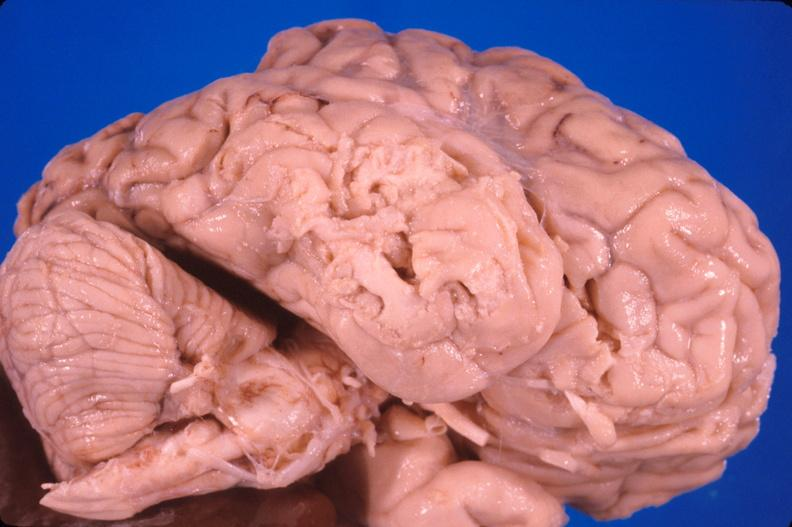s nervous present?
Answer the question using a single word or phrase. Yes 